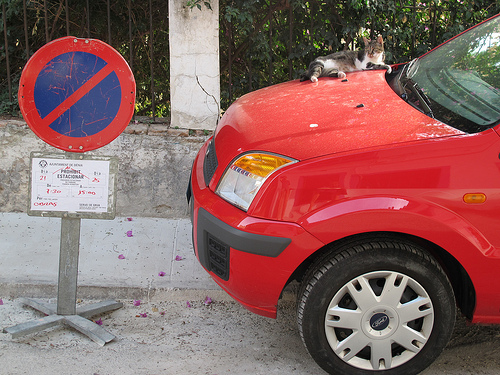<image>
Is the car in the not parking? Yes. The car is contained within or inside the not parking, showing a containment relationship. 